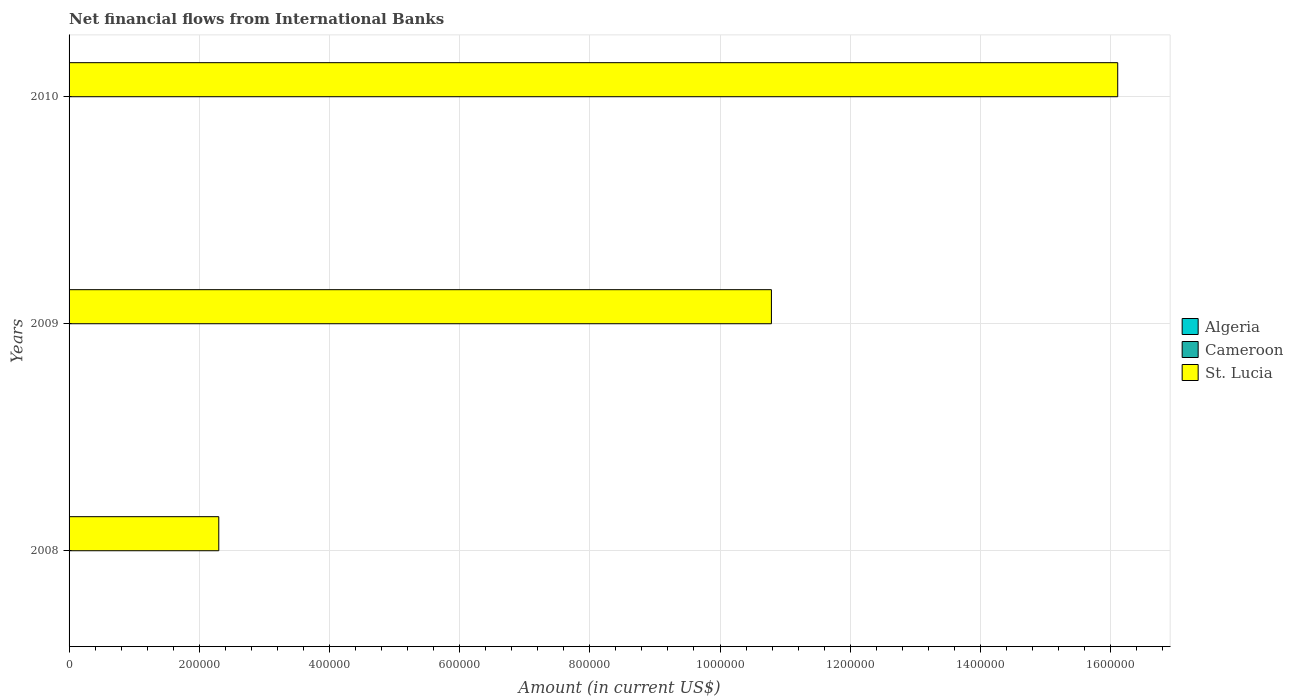How many different coloured bars are there?
Your answer should be compact. 1. Are the number of bars per tick equal to the number of legend labels?
Offer a very short reply. No. Are the number of bars on each tick of the Y-axis equal?
Your answer should be very brief. Yes. What is the label of the 1st group of bars from the top?
Make the answer very short. 2010. Across all years, what is the maximum net financial aid flows in St. Lucia?
Make the answer very short. 1.61e+06. What is the total net financial aid flows in St. Lucia in the graph?
Make the answer very short. 2.92e+06. What is the difference between the net financial aid flows in St. Lucia in 2008 and that in 2010?
Give a very brief answer. -1.38e+06. What is the average net financial aid flows in Cameroon per year?
Your answer should be very brief. 0. What is the ratio of the net financial aid flows in St. Lucia in 2008 to that in 2010?
Make the answer very short. 0.14. What is the difference between the highest and the lowest net financial aid flows in St. Lucia?
Your answer should be very brief. 1.38e+06. Is it the case that in every year, the sum of the net financial aid flows in Cameroon and net financial aid flows in Algeria is greater than the net financial aid flows in St. Lucia?
Ensure brevity in your answer.  No. How many years are there in the graph?
Offer a very short reply. 3. Are the values on the major ticks of X-axis written in scientific E-notation?
Offer a very short reply. No. Does the graph contain grids?
Ensure brevity in your answer.  Yes. Where does the legend appear in the graph?
Provide a short and direct response. Center right. How are the legend labels stacked?
Offer a very short reply. Vertical. What is the title of the graph?
Keep it short and to the point. Net financial flows from International Banks. What is the label or title of the X-axis?
Provide a short and direct response. Amount (in current US$). What is the Amount (in current US$) of Algeria in 2008?
Give a very brief answer. 0. What is the Amount (in current US$) in Cameroon in 2008?
Your answer should be compact. 0. What is the Amount (in current US$) in St. Lucia in 2008?
Provide a succinct answer. 2.30e+05. What is the Amount (in current US$) in Cameroon in 2009?
Offer a terse response. 0. What is the Amount (in current US$) of St. Lucia in 2009?
Make the answer very short. 1.08e+06. What is the Amount (in current US$) of Algeria in 2010?
Offer a very short reply. 0. What is the Amount (in current US$) in St. Lucia in 2010?
Keep it short and to the point. 1.61e+06. Across all years, what is the maximum Amount (in current US$) in St. Lucia?
Provide a succinct answer. 1.61e+06. What is the total Amount (in current US$) of Cameroon in the graph?
Keep it short and to the point. 0. What is the total Amount (in current US$) in St. Lucia in the graph?
Keep it short and to the point. 2.92e+06. What is the difference between the Amount (in current US$) in St. Lucia in 2008 and that in 2009?
Keep it short and to the point. -8.49e+05. What is the difference between the Amount (in current US$) of St. Lucia in 2008 and that in 2010?
Provide a succinct answer. -1.38e+06. What is the difference between the Amount (in current US$) of St. Lucia in 2009 and that in 2010?
Ensure brevity in your answer.  -5.32e+05. What is the average Amount (in current US$) of Cameroon per year?
Your response must be concise. 0. What is the average Amount (in current US$) of St. Lucia per year?
Your response must be concise. 9.73e+05. What is the ratio of the Amount (in current US$) of St. Lucia in 2008 to that in 2009?
Offer a very short reply. 0.21. What is the ratio of the Amount (in current US$) of St. Lucia in 2008 to that in 2010?
Your answer should be very brief. 0.14. What is the ratio of the Amount (in current US$) of St. Lucia in 2009 to that in 2010?
Your answer should be very brief. 0.67. What is the difference between the highest and the second highest Amount (in current US$) of St. Lucia?
Ensure brevity in your answer.  5.32e+05. What is the difference between the highest and the lowest Amount (in current US$) in St. Lucia?
Offer a very short reply. 1.38e+06. 